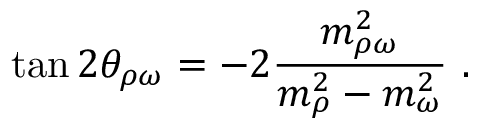Convert formula to latex. <formula><loc_0><loc_0><loc_500><loc_500>\tan 2 \theta _ { \rho \omega } = - 2 \frac { m _ { \rho \omega } ^ { 2 } } { m _ { \rho } ^ { 2 } - m _ { \omega } ^ { 2 } } .</formula> 